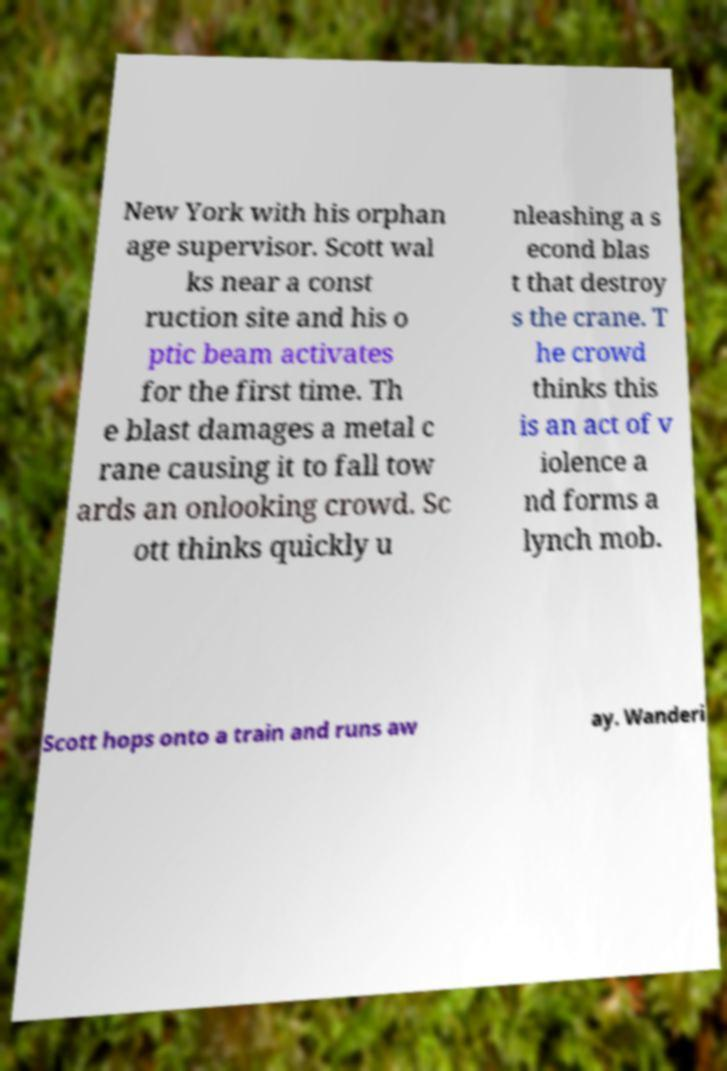Please identify and transcribe the text found in this image. New York with his orphan age supervisor. Scott wal ks near a const ruction site and his o ptic beam activates for the first time. Th e blast damages a metal c rane causing it to fall tow ards an onlooking crowd. Sc ott thinks quickly u nleashing a s econd blas t that destroy s the crane. T he crowd thinks this is an act of v iolence a nd forms a lynch mob. Scott hops onto a train and runs aw ay. Wanderi 